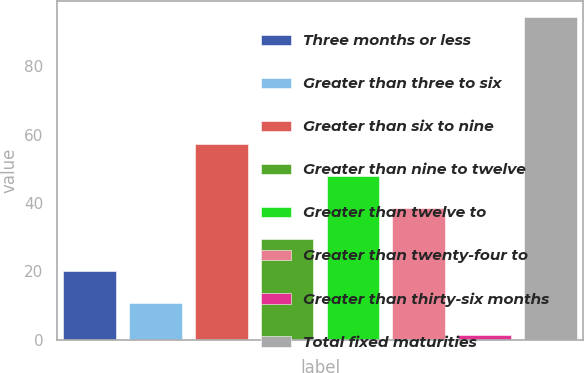Convert chart to OTSL. <chart><loc_0><loc_0><loc_500><loc_500><bar_chart><fcel>Three months or less<fcel>Greater than three to six<fcel>Greater than six to nine<fcel>Greater than nine to twelve<fcel>Greater than twelve to<fcel>Greater than twenty-four to<fcel>Greater than thirty-six months<fcel>Total fixed maturities<nl><fcel>20.08<fcel>10.79<fcel>57.24<fcel>29.37<fcel>47.95<fcel>38.66<fcel>1.5<fcel>94.4<nl></chart> 